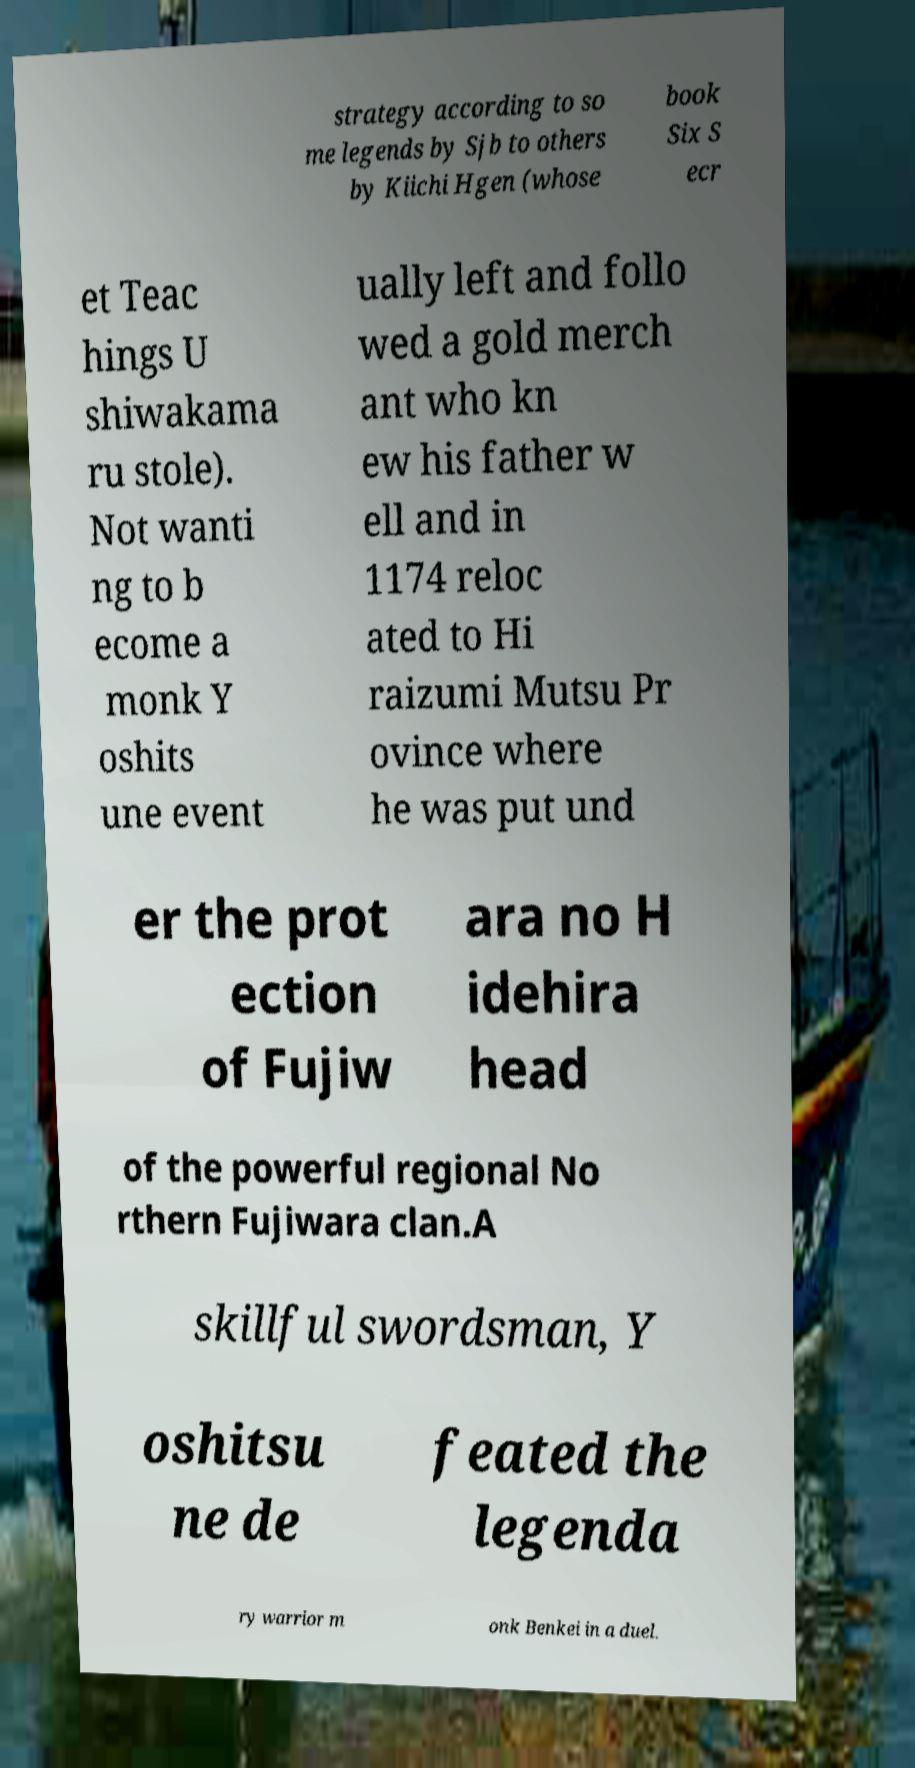For documentation purposes, I need the text within this image transcribed. Could you provide that? strategy according to so me legends by Sjb to others by Kiichi Hgen (whose book Six S ecr et Teac hings U shiwakama ru stole). Not wanti ng to b ecome a monk Y oshits une event ually left and follo wed a gold merch ant who kn ew his father w ell and in 1174 reloc ated to Hi raizumi Mutsu Pr ovince where he was put und er the prot ection of Fujiw ara no H idehira head of the powerful regional No rthern Fujiwara clan.A skillful swordsman, Y oshitsu ne de feated the legenda ry warrior m onk Benkei in a duel. 